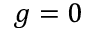Convert formula to latex. <formula><loc_0><loc_0><loc_500><loc_500>g = 0</formula> 